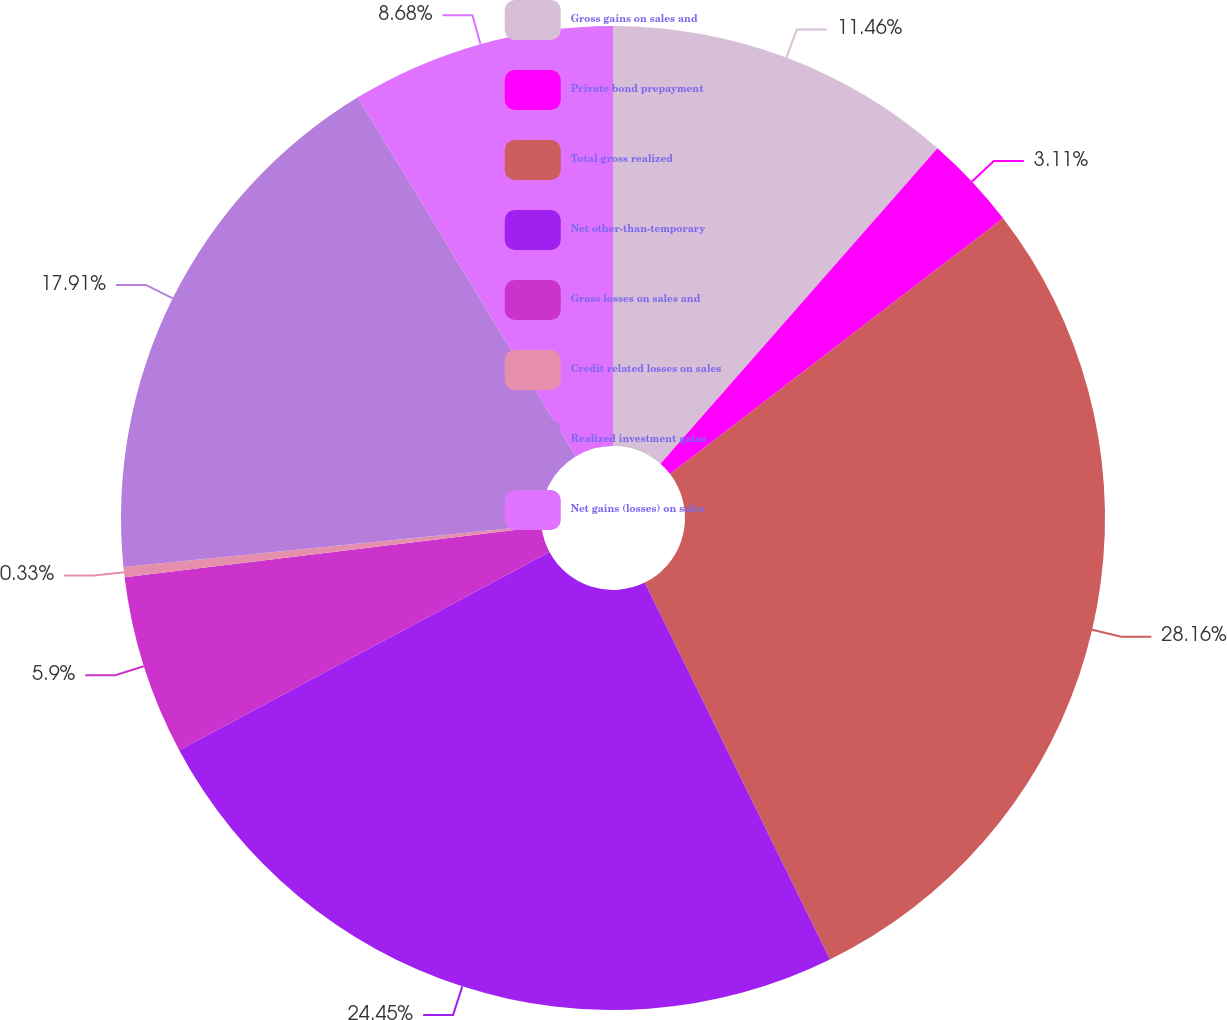Convert chart to OTSL. <chart><loc_0><loc_0><loc_500><loc_500><pie_chart><fcel>Gross gains on sales and<fcel>Private bond prepayment<fcel>Total gross realized<fcel>Net other-than-temporary<fcel>Gross losses on sales and<fcel>Credit related losses on sales<fcel>Realized investment gains<fcel>Net gains (losses) on sales<nl><fcel>11.46%<fcel>3.11%<fcel>28.16%<fcel>24.45%<fcel>5.9%<fcel>0.33%<fcel>17.91%<fcel>8.68%<nl></chart> 